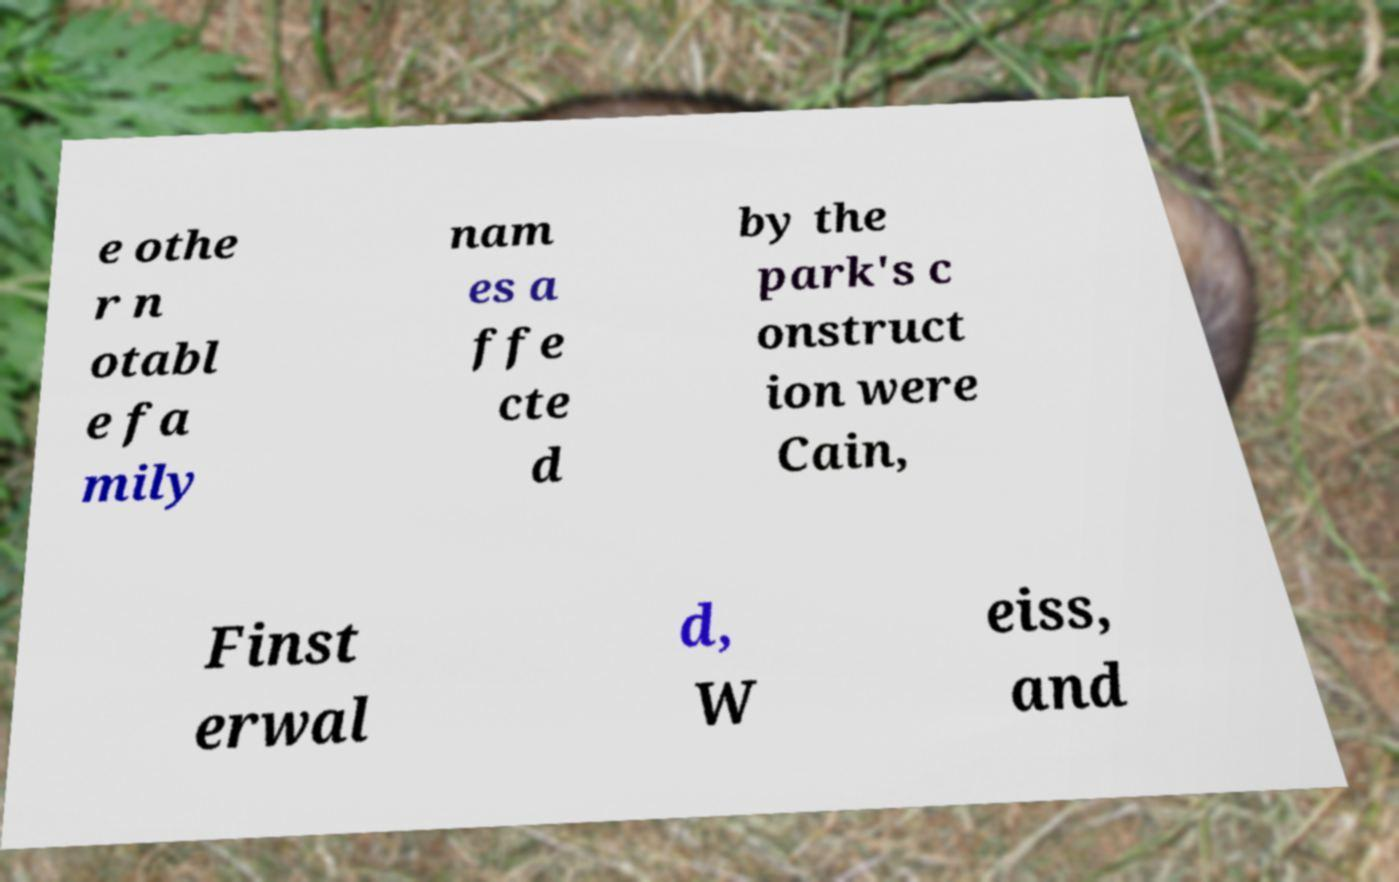What messages or text are displayed in this image? I need them in a readable, typed format. e othe r n otabl e fa mily nam es a ffe cte d by the park's c onstruct ion were Cain, Finst erwal d, W eiss, and 